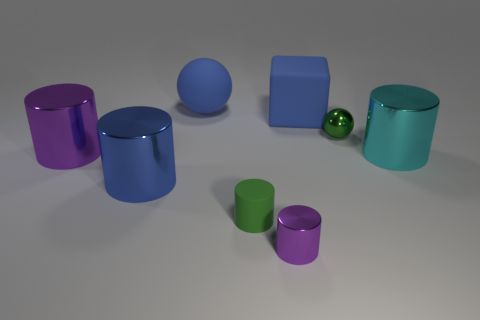Subtract 2 cylinders. How many cylinders are left? 3 Subtract all large blue cylinders. How many cylinders are left? 4 Subtract all cyan cylinders. How many cylinders are left? 4 Add 1 tiny purple things. How many objects exist? 9 Subtract all cyan cylinders. Subtract all yellow balls. How many cylinders are left? 4 Subtract all cylinders. How many objects are left? 3 Subtract 1 purple cylinders. How many objects are left? 7 Subtract all large yellow things. Subtract all blue rubber cubes. How many objects are left? 7 Add 5 blue spheres. How many blue spheres are left? 6 Add 8 cubes. How many cubes exist? 9 